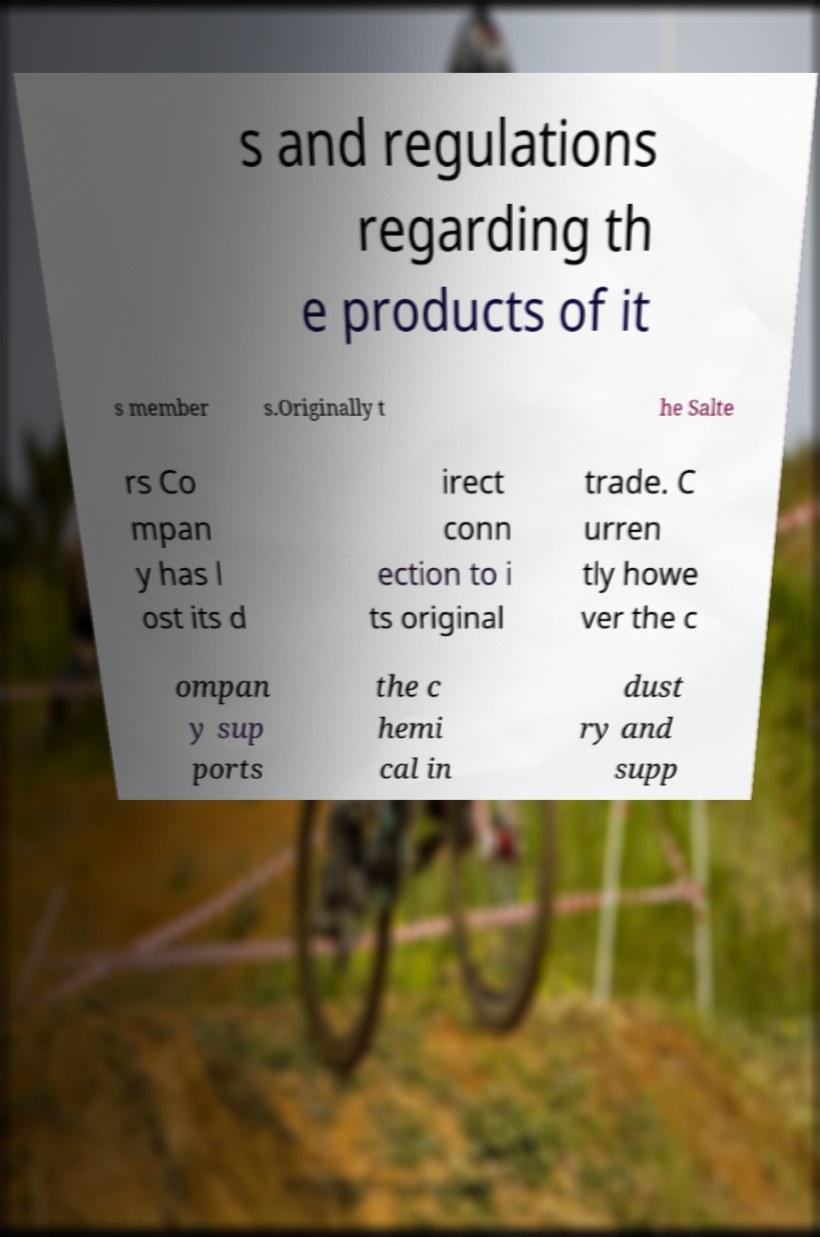Please identify and transcribe the text found in this image. s and regulations regarding th e products of it s member s.Originally t he Salte rs Co mpan y has l ost its d irect conn ection to i ts original trade. C urren tly howe ver the c ompan y sup ports the c hemi cal in dust ry and supp 